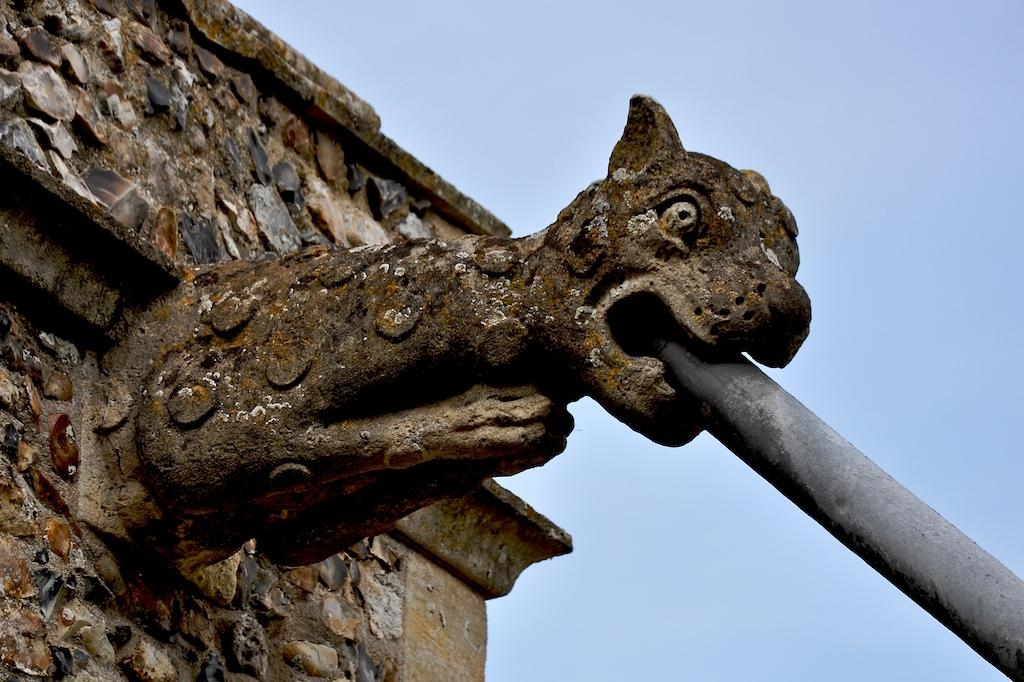What is the main subject of the picture? The main subject of the picture is a sculpture of an animal. What is the animal holding in its mouth? The sculpture has a pipe in its mouth. How is the pipe attached to the wall? The pipe is fixed to a stone wall. What can be seen in the background of the image? The background of the image includes the blue sky. What type of agreement is being discussed by the animal and the pipe in the image? There is no discussion or agreement present in the image; it features a sculpture of an animal with a pipe in its mouth. Can you tell me how many curves are visible in the pipe? The image does not provide enough detail to determine the number of curves in the pipe. 